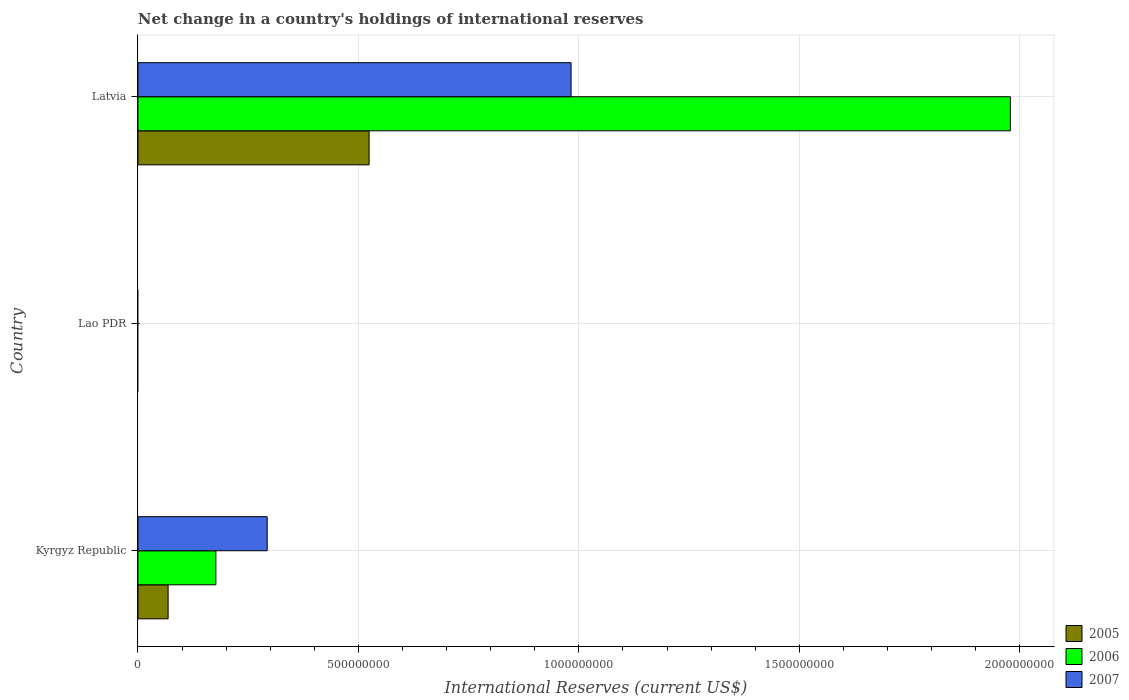Are the number of bars on each tick of the Y-axis equal?
Keep it short and to the point. No. What is the label of the 2nd group of bars from the top?
Provide a short and direct response. Lao PDR. In how many cases, is the number of bars for a given country not equal to the number of legend labels?
Provide a succinct answer. 1. What is the international reserves in 2006 in Kyrgyz Republic?
Provide a short and direct response. 1.77e+08. Across all countries, what is the maximum international reserves in 2007?
Your response must be concise. 9.82e+08. In which country was the international reserves in 2006 maximum?
Give a very brief answer. Latvia. What is the total international reserves in 2006 in the graph?
Your response must be concise. 2.16e+09. What is the difference between the international reserves in 2005 in Kyrgyz Republic and that in Latvia?
Give a very brief answer. -4.56e+08. What is the difference between the international reserves in 2006 in Lao PDR and the international reserves in 2005 in Latvia?
Your response must be concise. -5.24e+08. What is the average international reserves in 2005 per country?
Your response must be concise. 1.98e+08. What is the difference between the international reserves in 2007 and international reserves in 2005 in Kyrgyz Republic?
Offer a terse response. 2.25e+08. In how many countries, is the international reserves in 2005 greater than 500000000 US$?
Your answer should be compact. 1. What is the ratio of the international reserves in 2005 in Kyrgyz Republic to that in Latvia?
Your answer should be very brief. 0.13. Is the international reserves in 2005 in Kyrgyz Republic less than that in Latvia?
Offer a terse response. Yes. Is the difference between the international reserves in 2007 in Kyrgyz Republic and Latvia greater than the difference between the international reserves in 2005 in Kyrgyz Republic and Latvia?
Your answer should be very brief. No. What is the difference between the highest and the lowest international reserves in 2007?
Make the answer very short. 9.82e+08. In how many countries, is the international reserves in 2007 greater than the average international reserves in 2007 taken over all countries?
Offer a very short reply. 1. Is the sum of the international reserves in 2005 in Kyrgyz Republic and Latvia greater than the maximum international reserves in 2006 across all countries?
Your response must be concise. No. Is it the case that in every country, the sum of the international reserves in 2005 and international reserves in 2006 is greater than the international reserves in 2007?
Keep it short and to the point. No. Are all the bars in the graph horizontal?
Your answer should be compact. Yes. Are the values on the major ticks of X-axis written in scientific E-notation?
Provide a short and direct response. No. Does the graph contain grids?
Give a very brief answer. Yes. Where does the legend appear in the graph?
Ensure brevity in your answer.  Bottom right. How many legend labels are there?
Provide a short and direct response. 3. How are the legend labels stacked?
Offer a terse response. Vertical. What is the title of the graph?
Make the answer very short. Net change in a country's holdings of international reserves. What is the label or title of the X-axis?
Offer a very short reply. International Reserves (current US$). What is the label or title of the Y-axis?
Give a very brief answer. Country. What is the International Reserves (current US$) of 2005 in Kyrgyz Republic?
Offer a very short reply. 6.84e+07. What is the International Reserves (current US$) in 2006 in Kyrgyz Republic?
Your response must be concise. 1.77e+08. What is the International Reserves (current US$) in 2007 in Kyrgyz Republic?
Give a very brief answer. 2.93e+08. What is the International Reserves (current US$) of 2005 in Lao PDR?
Provide a succinct answer. 0. What is the International Reserves (current US$) in 2005 in Latvia?
Provide a succinct answer. 5.24e+08. What is the International Reserves (current US$) of 2006 in Latvia?
Your answer should be very brief. 1.98e+09. What is the International Reserves (current US$) in 2007 in Latvia?
Provide a succinct answer. 9.82e+08. Across all countries, what is the maximum International Reserves (current US$) in 2005?
Give a very brief answer. 5.24e+08. Across all countries, what is the maximum International Reserves (current US$) of 2006?
Make the answer very short. 1.98e+09. Across all countries, what is the maximum International Reserves (current US$) of 2007?
Provide a succinct answer. 9.82e+08. Across all countries, what is the minimum International Reserves (current US$) of 2005?
Offer a terse response. 0. Across all countries, what is the minimum International Reserves (current US$) in 2006?
Keep it short and to the point. 0. What is the total International Reserves (current US$) in 2005 in the graph?
Make the answer very short. 5.93e+08. What is the total International Reserves (current US$) in 2006 in the graph?
Provide a short and direct response. 2.16e+09. What is the total International Reserves (current US$) in 2007 in the graph?
Keep it short and to the point. 1.28e+09. What is the difference between the International Reserves (current US$) of 2005 in Kyrgyz Republic and that in Latvia?
Offer a very short reply. -4.56e+08. What is the difference between the International Reserves (current US$) in 2006 in Kyrgyz Republic and that in Latvia?
Ensure brevity in your answer.  -1.80e+09. What is the difference between the International Reserves (current US$) in 2007 in Kyrgyz Republic and that in Latvia?
Offer a terse response. -6.89e+08. What is the difference between the International Reserves (current US$) in 2005 in Kyrgyz Republic and the International Reserves (current US$) in 2006 in Latvia?
Your response must be concise. -1.91e+09. What is the difference between the International Reserves (current US$) in 2005 in Kyrgyz Republic and the International Reserves (current US$) in 2007 in Latvia?
Keep it short and to the point. -9.14e+08. What is the difference between the International Reserves (current US$) in 2006 in Kyrgyz Republic and the International Reserves (current US$) in 2007 in Latvia?
Keep it short and to the point. -8.06e+08. What is the average International Reserves (current US$) of 2005 per country?
Give a very brief answer. 1.98e+08. What is the average International Reserves (current US$) of 2006 per country?
Your answer should be compact. 7.18e+08. What is the average International Reserves (current US$) in 2007 per country?
Give a very brief answer. 4.25e+08. What is the difference between the International Reserves (current US$) of 2005 and International Reserves (current US$) of 2006 in Kyrgyz Republic?
Make the answer very short. -1.08e+08. What is the difference between the International Reserves (current US$) in 2005 and International Reserves (current US$) in 2007 in Kyrgyz Republic?
Make the answer very short. -2.25e+08. What is the difference between the International Reserves (current US$) of 2006 and International Reserves (current US$) of 2007 in Kyrgyz Republic?
Give a very brief answer. -1.16e+08. What is the difference between the International Reserves (current US$) in 2005 and International Reserves (current US$) in 2006 in Latvia?
Offer a very short reply. -1.45e+09. What is the difference between the International Reserves (current US$) of 2005 and International Reserves (current US$) of 2007 in Latvia?
Keep it short and to the point. -4.58e+08. What is the difference between the International Reserves (current US$) of 2006 and International Reserves (current US$) of 2007 in Latvia?
Your answer should be compact. 9.96e+08. What is the ratio of the International Reserves (current US$) of 2005 in Kyrgyz Republic to that in Latvia?
Offer a very short reply. 0.13. What is the ratio of the International Reserves (current US$) in 2006 in Kyrgyz Republic to that in Latvia?
Make the answer very short. 0.09. What is the ratio of the International Reserves (current US$) in 2007 in Kyrgyz Republic to that in Latvia?
Give a very brief answer. 0.3. What is the difference between the highest and the lowest International Reserves (current US$) in 2005?
Give a very brief answer. 5.24e+08. What is the difference between the highest and the lowest International Reserves (current US$) in 2006?
Offer a very short reply. 1.98e+09. What is the difference between the highest and the lowest International Reserves (current US$) in 2007?
Make the answer very short. 9.82e+08. 